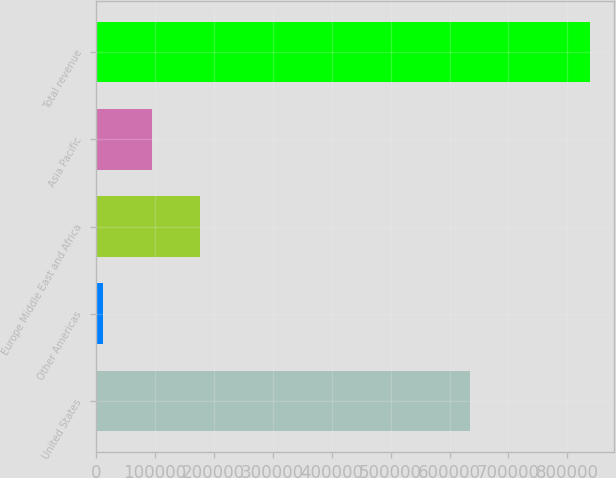Convert chart to OTSL. <chart><loc_0><loc_0><loc_500><loc_500><bar_chart><fcel>United States<fcel>Other Americas<fcel>Europe Middle East and Africa<fcel>Asia Pacific<fcel>Total revenue<nl><fcel>634413<fcel>12506<fcel>177523<fcel>95014.5<fcel>837591<nl></chart> 